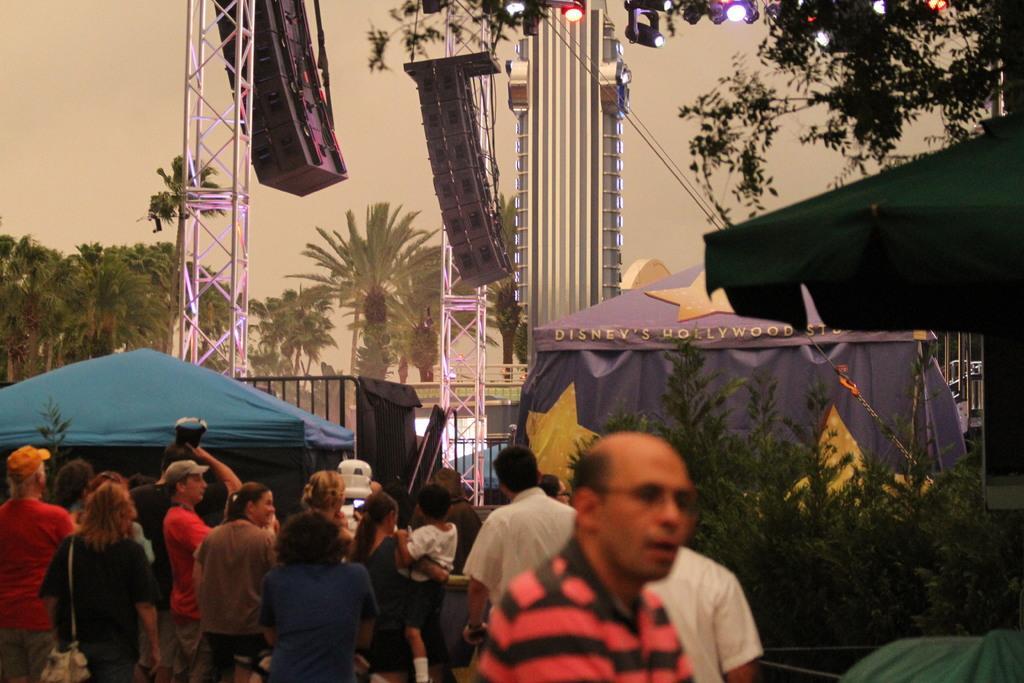Describe this image in one or two sentences. This picture consists of group of people , tents , trees, towers,and the sky visible, at the top there are few colorful lights. 